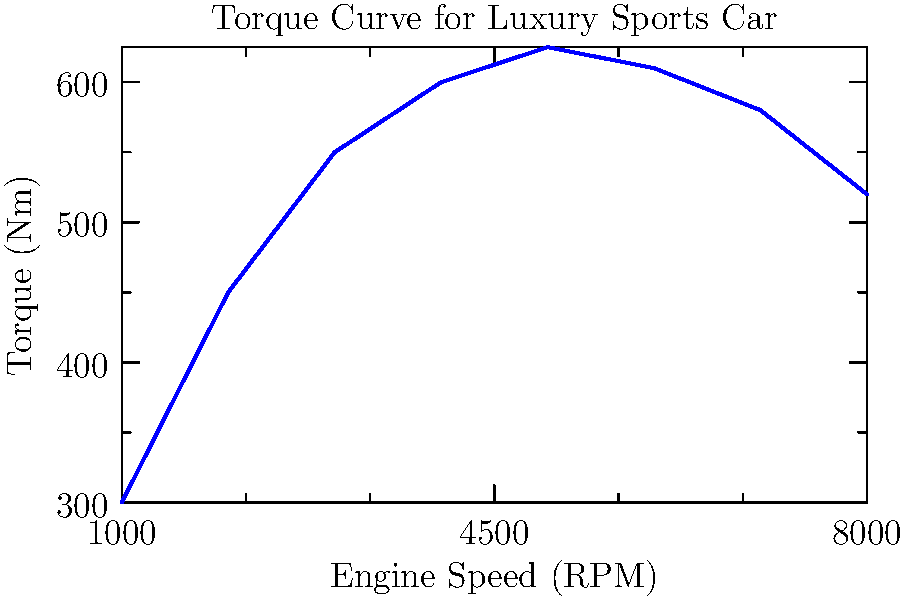Analyze the torque curve graph for a high-performance luxury sports car. At what engine speed (RPM) does the car achieve its peak torque, and what is the maximum torque value? To determine the peak torque and corresponding engine speed, we need to follow these steps:

1. Examine the y-axis (Torque) to identify the highest point on the curve.
2. From this highest point, trace horizontally to the y-axis to read the maximum torque value.
3. From the same highest point, trace vertically down to the x-axis to read the corresponding engine speed.

Looking at the graph:

1. The highest point on the curve appears to be at the apex of the curve.
2. This point corresponds to approximately 625 Nm on the y-axis.
3. Tracing down from this point, we can see it aligns with 5000 RPM on the x-axis.

Therefore, the peak torque of approximately 625 Nm is achieved at an engine speed of 5000 RPM.

It's worth noting that in real-world scenarios, luxury car dealers often need to interpret such graphs to explain vehicle performance characteristics to discerning customers interested in high-performance, limited-edition vehicles.
Answer: 625 Nm at 5000 RPM 